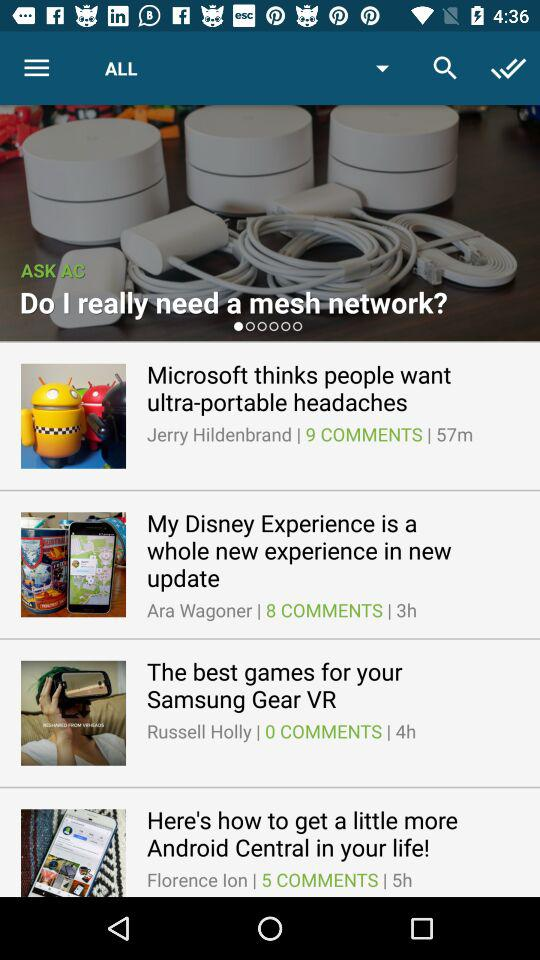What's the number of comments on "The best games for your Samsung Gear VR"? The number of comments is 0. 